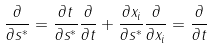Convert formula to latex. <formula><loc_0><loc_0><loc_500><loc_500>\frac { \partial } { \partial s ^ { * } } = \frac { \partial t } { \partial s ^ { * } } \frac { \partial } { \partial t } + \frac { \partial x _ { i } } { \partial s ^ { * } } \frac { \partial } { \partial x _ { i } } = \frac { \partial } { \partial t }</formula> 